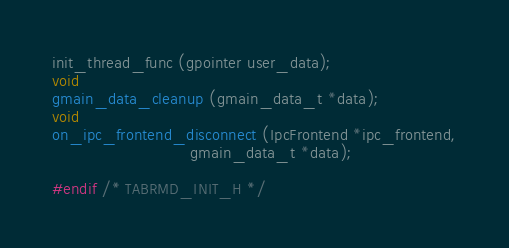<code> <loc_0><loc_0><loc_500><loc_500><_C_>init_thread_func (gpointer user_data);
void
gmain_data_cleanup (gmain_data_t *data);
void
on_ipc_frontend_disconnect (IpcFrontend *ipc_frontend,
                            gmain_data_t *data);

#endif /* TABRMD_INIT_H */
</code> 